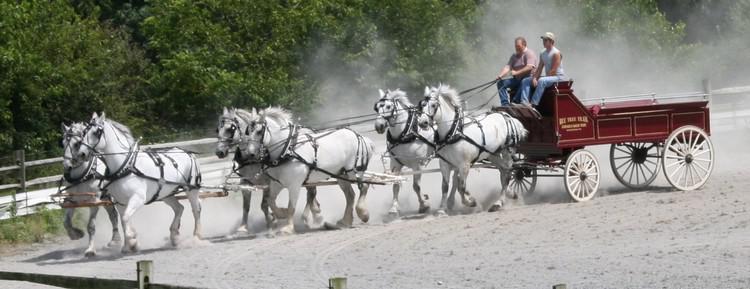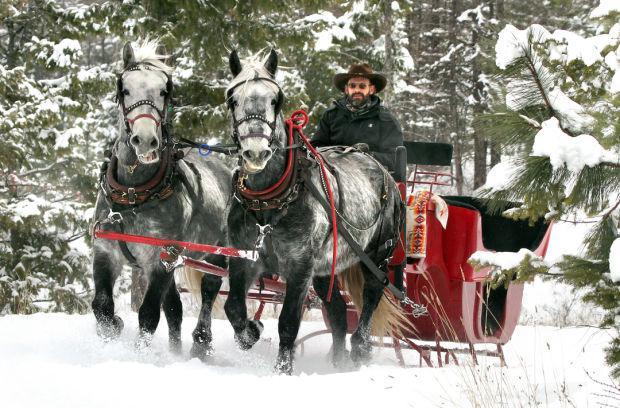The first image is the image on the left, the second image is the image on the right. Considering the images on both sides, is "There are more than five white horses in one of the images." valid? Answer yes or no. Yes. The first image is the image on the left, the second image is the image on the right. For the images shown, is this caption "A man is riding a horse pulled sleigh through the snow in the right image." true? Answer yes or no. Yes. 